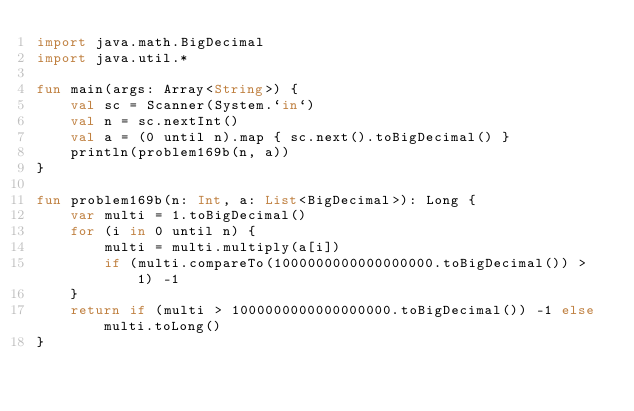Convert code to text. <code><loc_0><loc_0><loc_500><loc_500><_Kotlin_>import java.math.BigDecimal
import java.util.*

fun main(args: Array<String>) {
    val sc = Scanner(System.`in`)
    val n = sc.nextInt()
    val a = (0 until n).map { sc.next().toBigDecimal() }
    println(problem169b(n, a))
}

fun problem169b(n: Int, a: List<BigDecimal>): Long {
    var multi = 1.toBigDecimal()
    for (i in 0 until n) {
        multi = multi.multiply(a[i])
        if (multi.compareTo(1000000000000000000.toBigDecimal()) > 1) -1
    }
    return if (multi > 1000000000000000000.toBigDecimal()) -1 else multi.toLong()
}</code> 